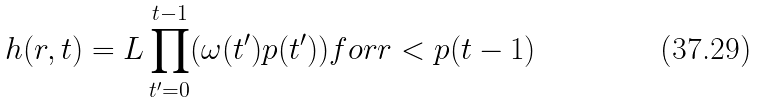<formula> <loc_0><loc_0><loc_500><loc_500>h ( r , t ) = L \prod _ { t ^ { \prime } = 0 } ^ { t - 1 } ( \omega ( t ^ { \prime } ) p ( t ^ { \prime } ) ) f o r r < p ( t - 1 )</formula> 